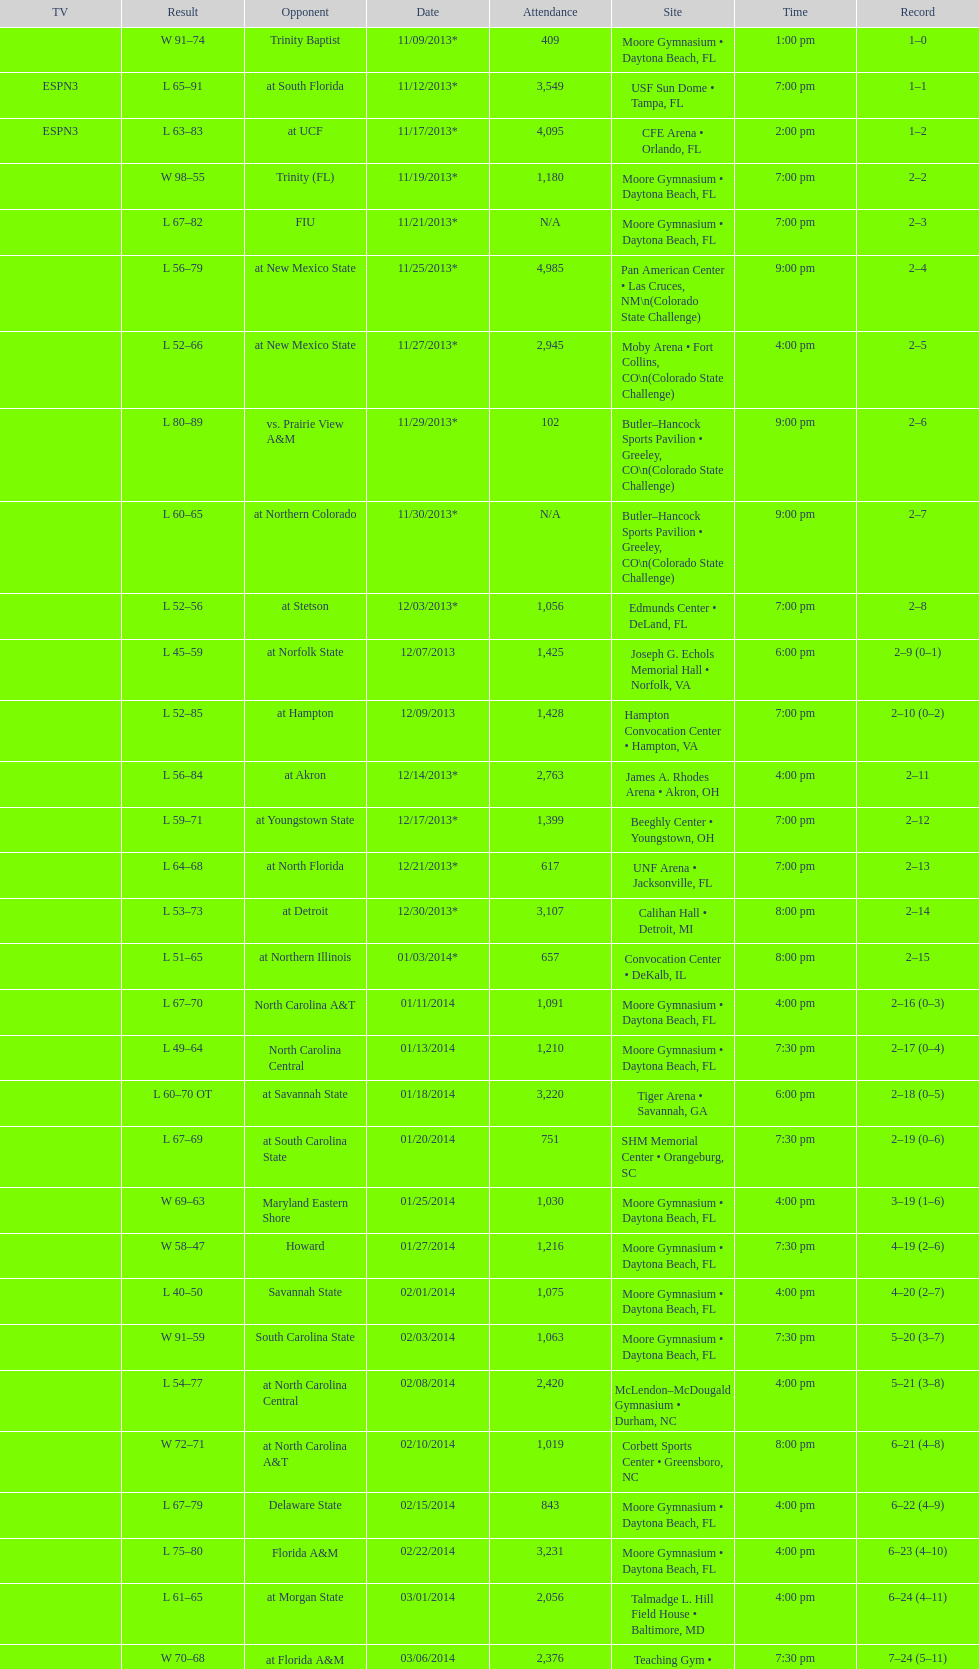In daytona beach, fl, how many games were played by the wildcats? 11. 